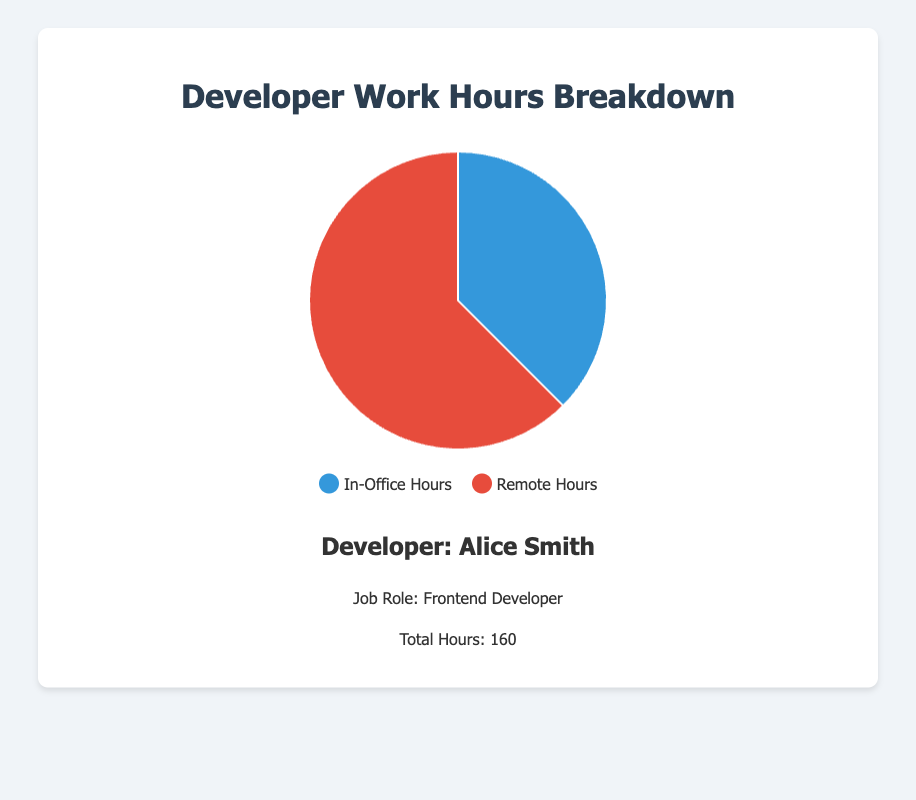What's the percentage of remote hours for Alice Smith? Alice Smith has 100 remote hours out of a total of 160 hours. The percentage is calculated as (100/160) * 100 = 62.5%
Answer: 62.5% Which developer has the most in-office hours? The developers have the following in-office hours: Alice Smith (60), Bob Johnson (80), Charlie Brown (40), Dana White (100), Eliotte Green (90). Dana White has the most in-office hours with 100 hours.
Answer: Dana White What is the total number of remote hours for Bob Johnson and Charlie Brown combined? Bob Johnson has 80 remote hours and Charlie Brown has 120 remote hours. Adding them together, 80 + 120 = 200 remote hours.
Answer: 200 Who has a higher percentage of remote hours, Alice Smith or Eliotte Green? Alice Smith's remote hours percentage is (100/160) * 100 = 62.5%. Eliotte Green's remote hours percentage is (70/160) * 100 = 43.75%. Alice Smith has a higher percentage of remote hours.
Answer: Alice Smith What is the difference in in-office hours between Dana White and Charlie Brown? Dana White has 100 in-office hours, and Charlie Brown has 40 in-office hours. The difference is 100 - 40 = 60 hours.
Answer: 60 Which developer's work hours are equally split between in-office and remote work? Bob Johnson has 80 in-office hours and 80 remote hours, which are equally split.
Answer: Bob Johnson Is there any developer whose in-office hours percentage is greater than 50%? Dana White has 100 in-office hours out of 160, which is (100/160) * 100 = 62.5%. Eliotte Green has 90 in-office hours out of 160, which is (90/160) * 100 = 56.25%. Both Dana White and Eliotte Green have in-office hours percentage greater than 50%.
Answer: Dana White and Eliotte Green Which developer has the lowest proportion of in-office hours? The proportions of in-office hours are as follows: Alice Smith (60/160 = 37.5%), Bob Johnson (80/160 = 50%), Charlie Brown (40/160 = 25%), Dana White (100/160 = 62.5%), Eliotte Green (90/160 = 56.25%). Charlie Brown has the lowest proportion of in-office hours with 25%.
Answer: Charlie Brown Can you determine the total number of in-office hours for all developers combined? Adding the in-office hours of all developers: 60 (Alice Smith) + 80 (Bob Johnson) + 40 (Charlie Brown) + 100 (Dana White) + 90 (Eliotte Green) = 370 hours.
Answer: 370 